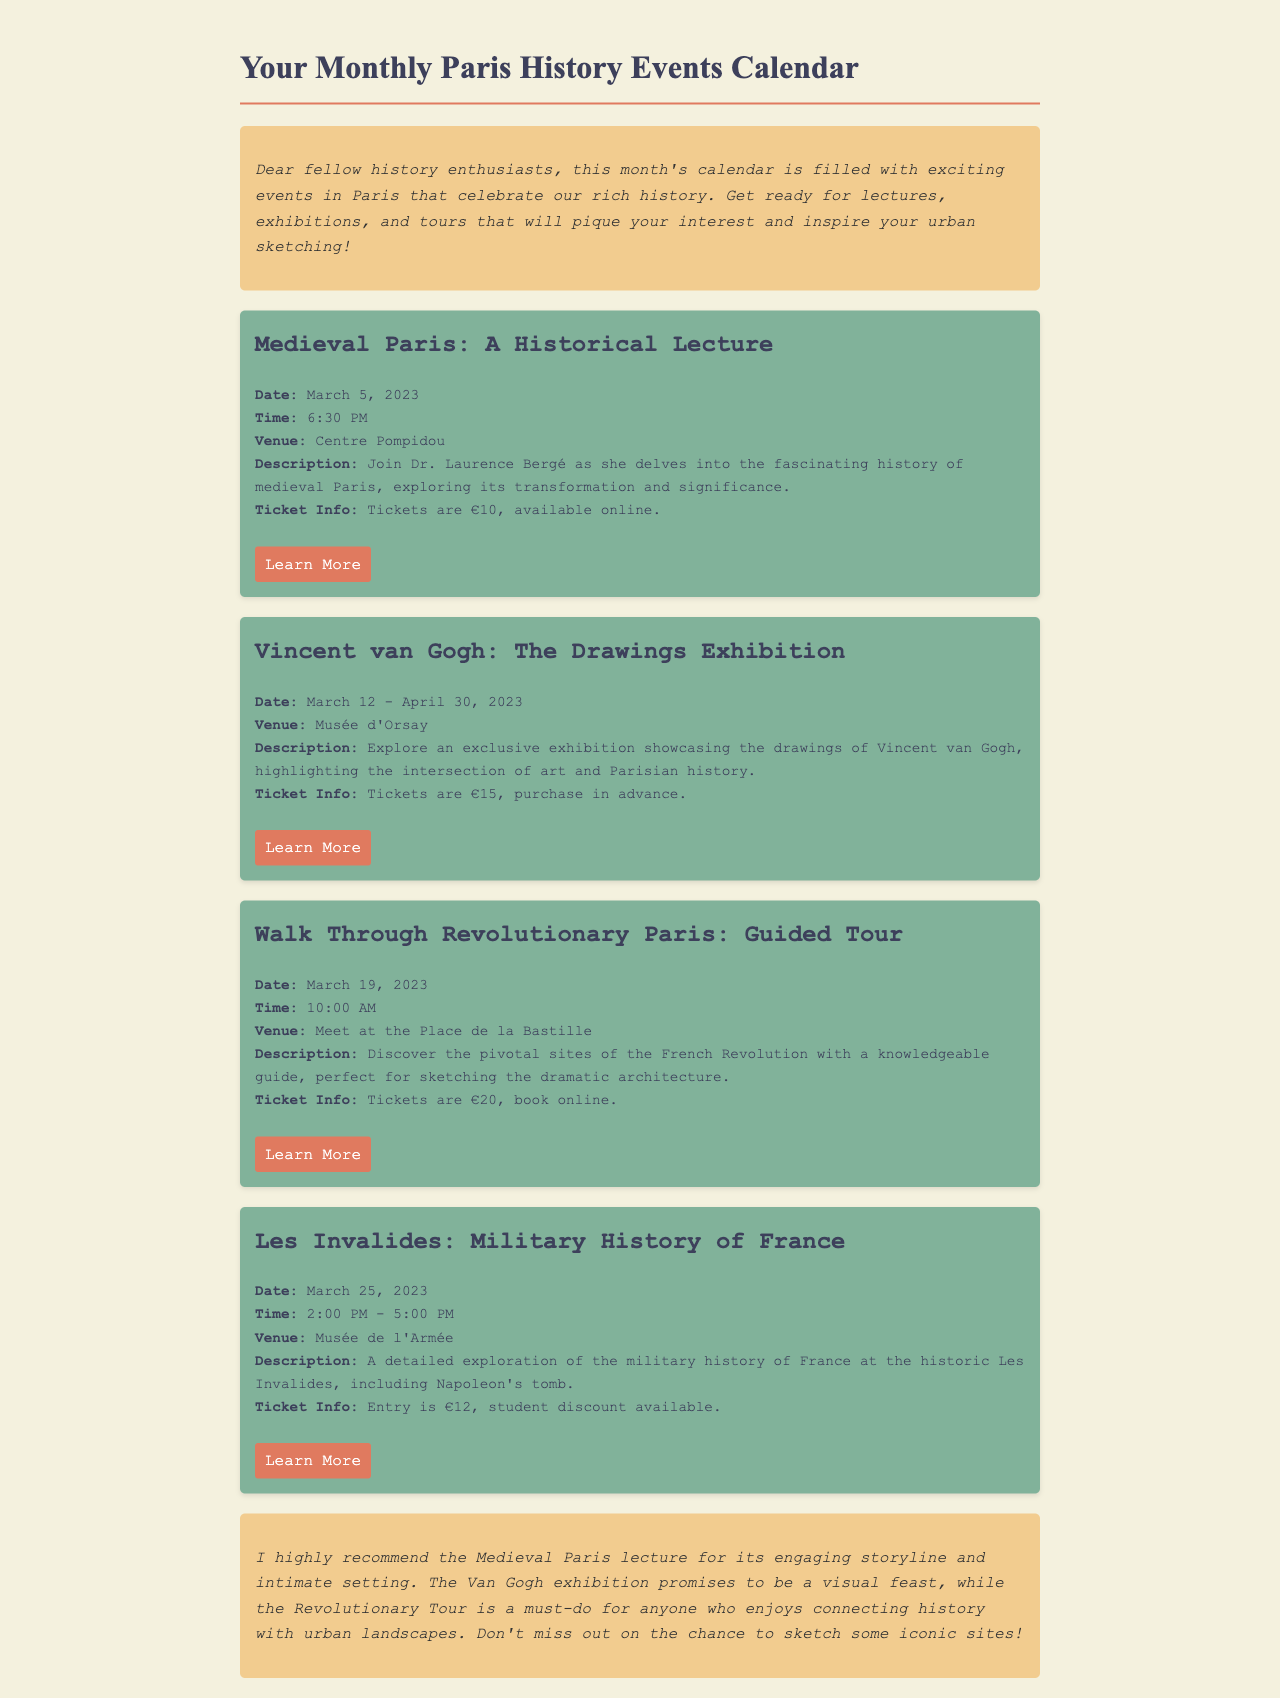what is the date of the Medieval Paris lecture? The date is specified in the event details.
Answer: March 5, 2023 what is the ticket price for the Van Gogh exhibition? The ticket info section mentions the price for this exhibition.
Answer: €15 where is the Guided Tour starting point? The venue details indicate where participants should meet.
Answer: Place de la Bastille who is giving the lecture on Medieval Paris? The event description includes the name of the lecturer.
Answer: Dr. Laurence Bergé what is the duration of the Les Invalides event? The event details provide the time frame for this event.
Answer: 2:00 PM - 5:00 PM which exhibition is focused on the drawings of Vincent van Gogh? The title of the event specifies the exhibition focus.
Answer: Vincent van Gogh: The Drawings Exhibition what is recommended for sketching in the Revolutionary Tour? The personal notes suggest an activity related to the tour.
Answer: sketching the dramatic architecture how much do tickets cost for the Revolutionary Tour? The ticket info for this event provides the cost for participation.
Answer: €20 